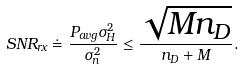Convert formula to latex. <formula><loc_0><loc_0><loc_500><loc_500>S N R _ { r x } \doteq \frac { P _ { a v g } \sigma _ { H } ^ { 2 } } { \sigma _ { n } ^ { 2 } } \leq \frac { \sqrt { M n _ { D } } } { n _ { D } + M } .</formula> 